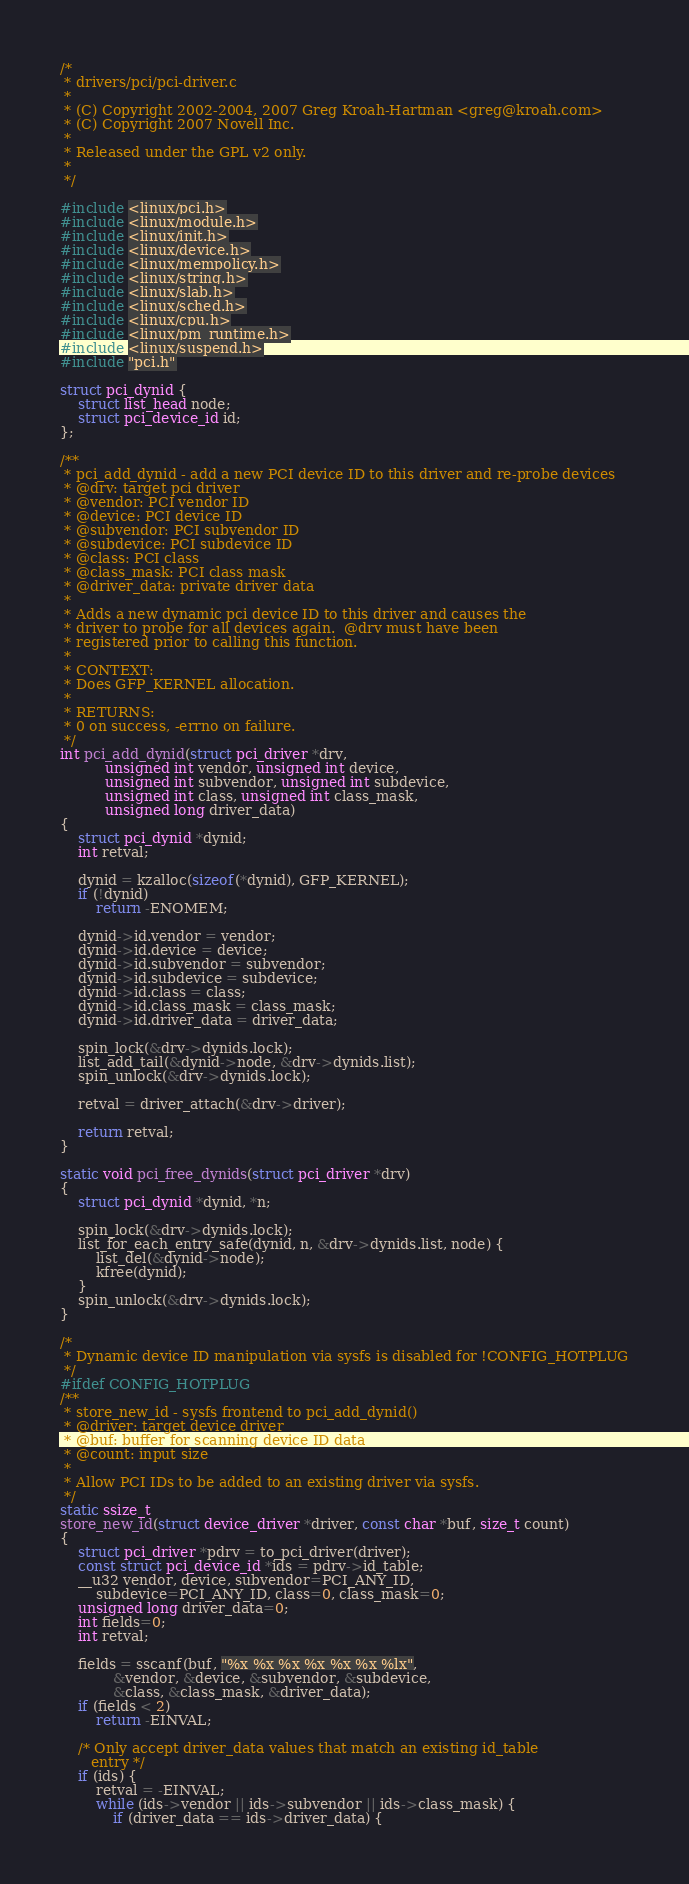<code> <loc_0><loc_0><loc_500><loc_500><_C_>/*
 * drivers/pci/pci-driver.c
 *
 * (C) Copyright 2002-2004, 2007 Greg Kroah-Hartman <greg@kroah.com>
 * (C) Copyright 2007 Novell Inc.
 *
 * Released under the GPL v2 only.
 *
 */

#include <linux/pci.h>
#include <linux/module.h>
#include <linux/init.h>
#include <linux/device.h>
#include <linux/mempolicy.h>
#include <linux/string.h>
#include <linux/slab.h>
#include <linux/sched.h>
#include <linux/cpu.h>
#include <linux/pm_runtime.h>
#include <linux/suspend.h>
#include "pci.h"

struct pci_dynid {
	struct list_head node;
	struct pci_device_id id;
};

/**
 * pci_add_dynid - add a new PCI device ID to this driver and re-probe devices
 * @drv: target pci driver
 * @vendor: PCI vendor ID
 * @device: PCI device ID
 * @subvendor: PCI subvendor ID
 * @subdevice: PCI subdevice ID
 * @class: PCI class
 * @class_mask: PCI class mask
 * @driver_data: private driver data
 *
 * Adds a new dynamic pci device ID to this driver and causes the
 * driver to probe for all devices again.  @drv must have been
 * registered prior to calling this function.
 *
 * CONTEXT:
 * Does GFP_KERNEL allocation.
 *
 * RETURNS:
 * 0 on success, -errno on failure.
 */
int pci_add_dynid(struct pci_driver *drv,
		  unsigned int vendor, unsigned int device,
		  unsigned int subvendor, unsigned int subdevice,
		  unsigned int class, unsigned int class_mask,
		  unsigned long driver_data)
{
	struct pci_dynid *dynid;
	int retval;

	dynid = kzalloc(sizeof(*dynid), GFP_KERNEL);
	if (!dynid)
		return -ENOMEM;

	dynid->id.vendor = vendor;
	dynid->id.device = device;
	dynid->id.subvendor = subvendor;
	dynid->id.subdevice = subdevice;
	dynid->id.class = class;
	dynid->id.class_mask = class_mask;
	dynid->id.driver_data = driver_data;

	spin_lock(&drv->dynids.lock);
	list_add_tail(&dynid->node, &drv->dynids.list);
	spin_unlock(&drv->dynids.lock);

	retval = driver_attach(&drv->driver);

	return retval;
}

static void pci_free_dynids(struct pci_driver *drv)
{
	struct pci_dynid *dynid, *n;

	spin_lock(&drv->dynids.lock);
	list_for_each_entry_safe(dynid, n, &drv->dynids.list, node) {
		list_del(&dynid->node);
		kfree(dynid);
	}
	spin_unlock(&drv->dynids.lock);
}

/*
 * Dynamic device ID manipulation via sysfs is disabled for !CONFIG_HOTPLUG
 */
#ifdef CONFIG_HOTPLUG
/**
 * store_new_id - sysfs frontend to pci_add_dynid()
 * @driver: target device driver
 * @buf: buffer for scanning device ID data
 * @count: input size
 *
 * Allow PCI IDs to be added to an existing driver via sysfs.
 */
static ssize_t
store_new_id(struct device_driver *driver, const char *buf, size_t count)
{
	struct pci_driver *pdrv = to_pci_driver(driver);
	const struct pci_device_id *ids = pdrv->id_table;
	__u32 vendor, device, subvendor=PCI_ANY_ID,
		subdevice=PCI_ANY_ID, class=0, class_mask=0;
	unsigned long driver_data=0;
	int fields=0;
	int retval;

	fields = sscanf(buf, "%x %x %x %x %x %x %lx",
			&vendor, &device, &subvendor, &subdevice,
			&class, &class_mask, &driver_data);
	if (fields < 2)
		return -EINVAL;

	/* Only accept driver_data values that match an existing id_table
	   entry */
	if (ids) {
		retval = -EINVAL;
		while (ids->vendor || ids->subvendor || ids->class_mask) {
			if (driver_data == ids->driver_data) {</code> 